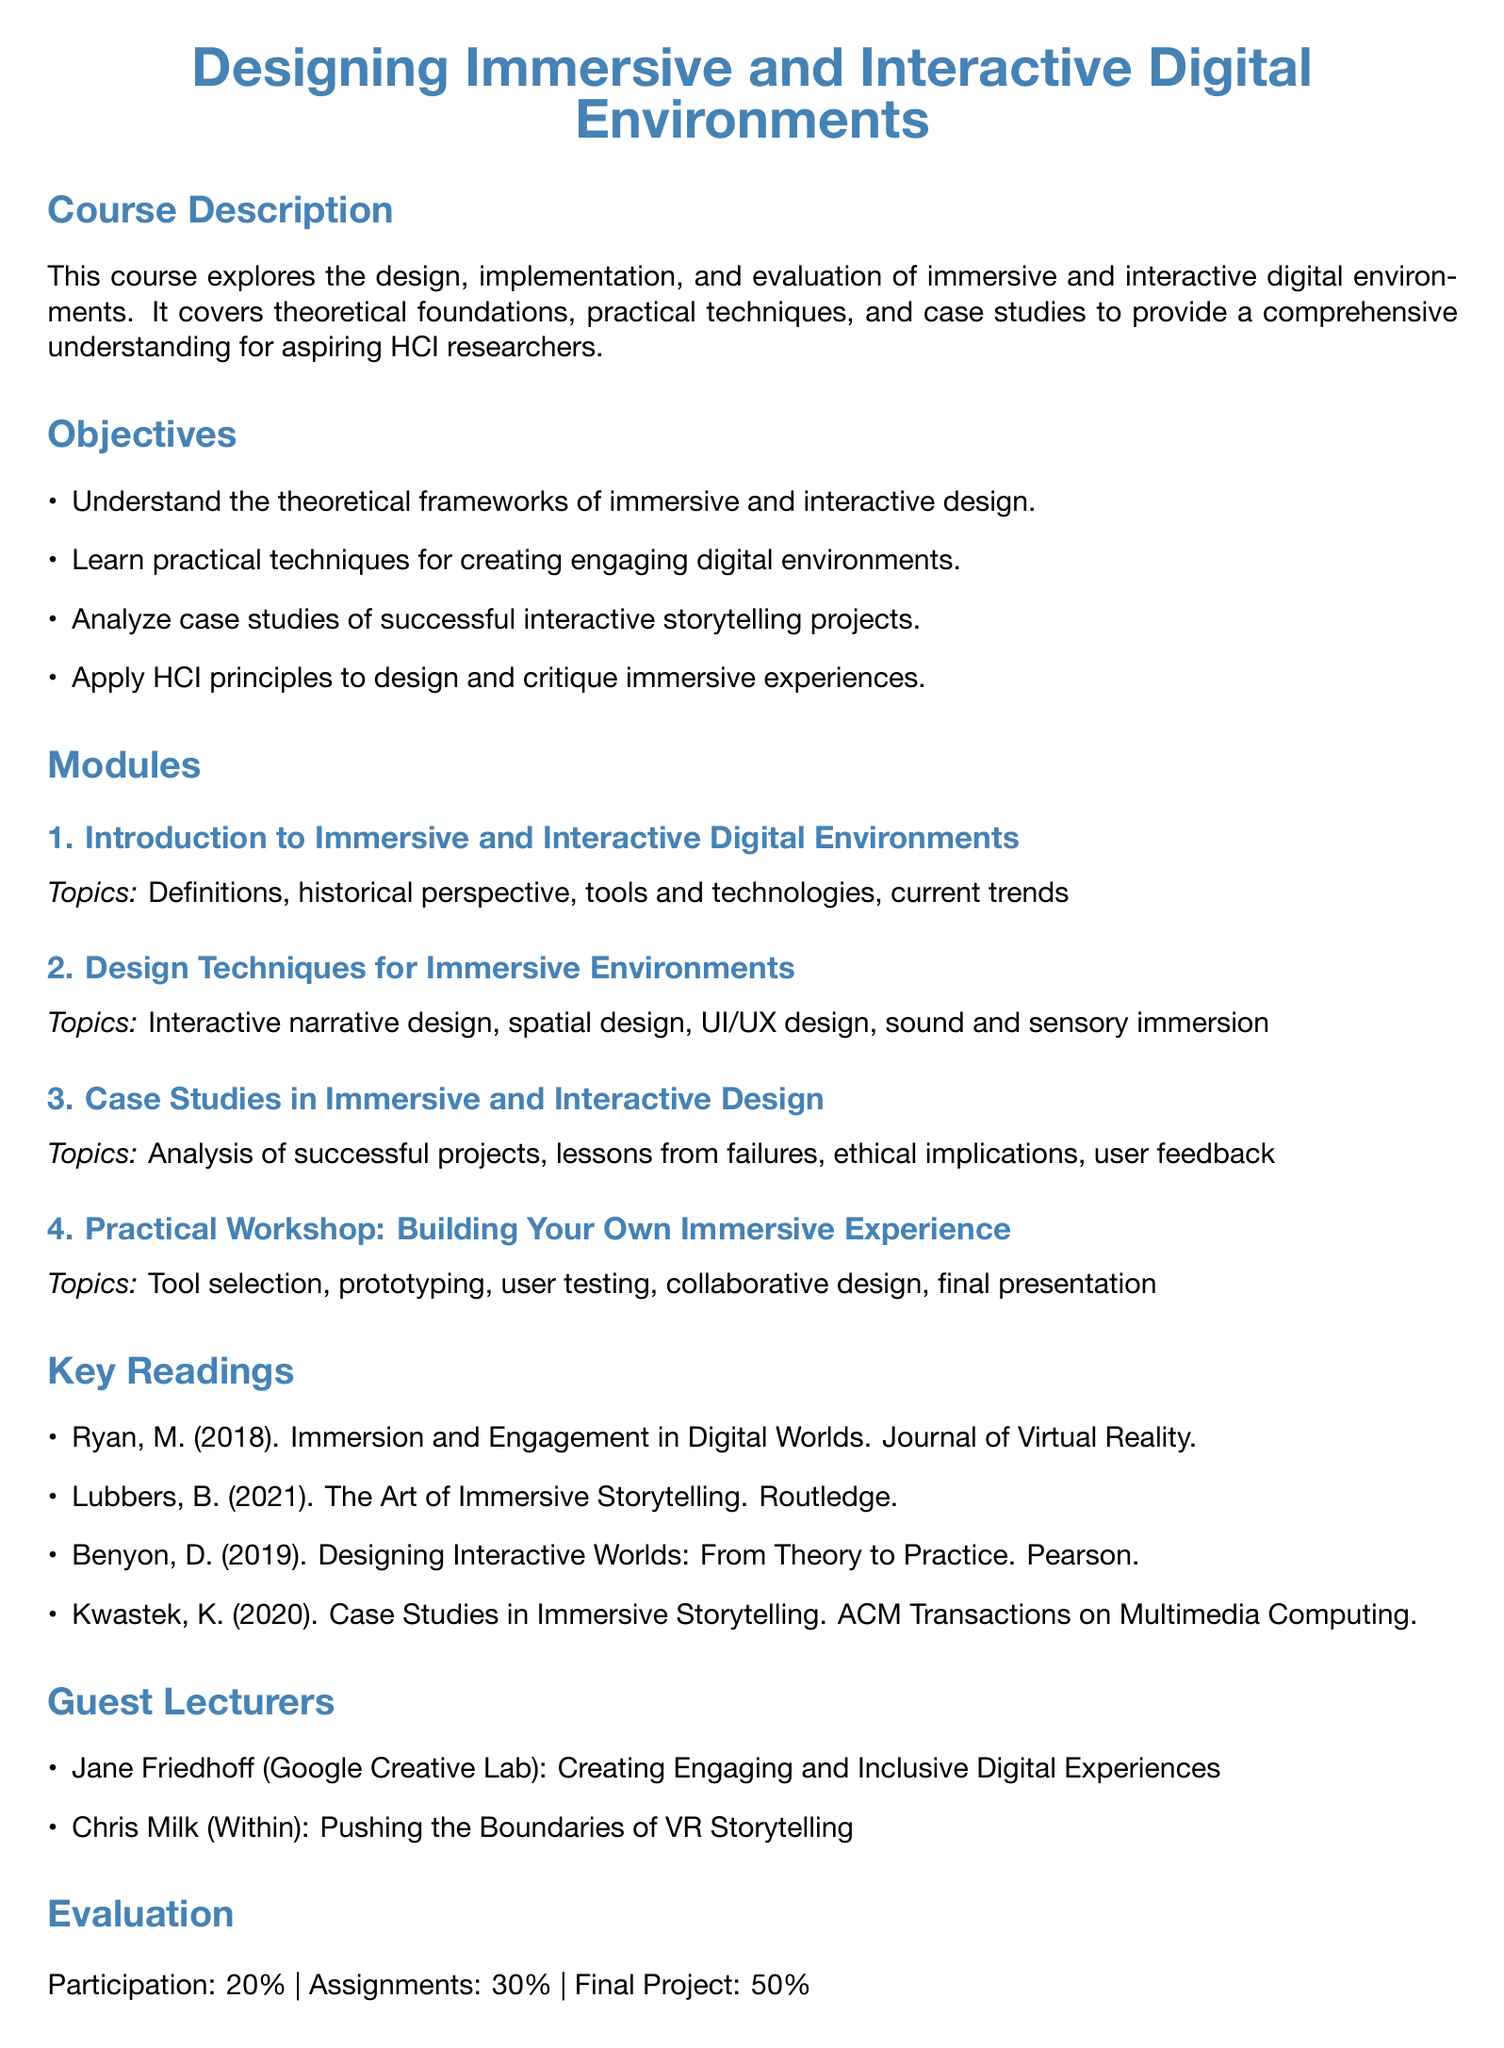What is the course title? The course title is specified at the beginning of the document.
Answer: Designing Immersive and Interactive Digital Environments How many objectives are listed? The number of objectives can be counted from the Objectives section of the document.
Answer: Four Who is a guest lecturer from Google Creative Lab? The document lists guest lecturers and their affiliations.
Answer: Jane Friedhoff What percentage of the evaluation is based on participation? The evaluation breakdown shows the percentage for each component.
Answer: 20% What is the final project about? The final project description can be found at the end of the document.
Answer: Design and implement a small-scale immersive digital environment What module covers interactive narrative design? Each module covers specific topics which can be identified in the Modules section.
Answer: Design Techniques for Immersive Environments Which reading is about case studies in immersive storytelling? The key readings section lists various readings, one of which mentions case studies.
Answer: Kwastek, K. (2020). Case Studies in Immersive Storytelling What is one of the practical workshop topics? The Practical Workshop section lists topics related to building immersive experiences.
Answer: User testing What are the prerequisites for the course? The prerequisites can be found at the bottom of the document.
Answer: Introduction to Human-Computer Interaction, Basics of Digital Media and Design 